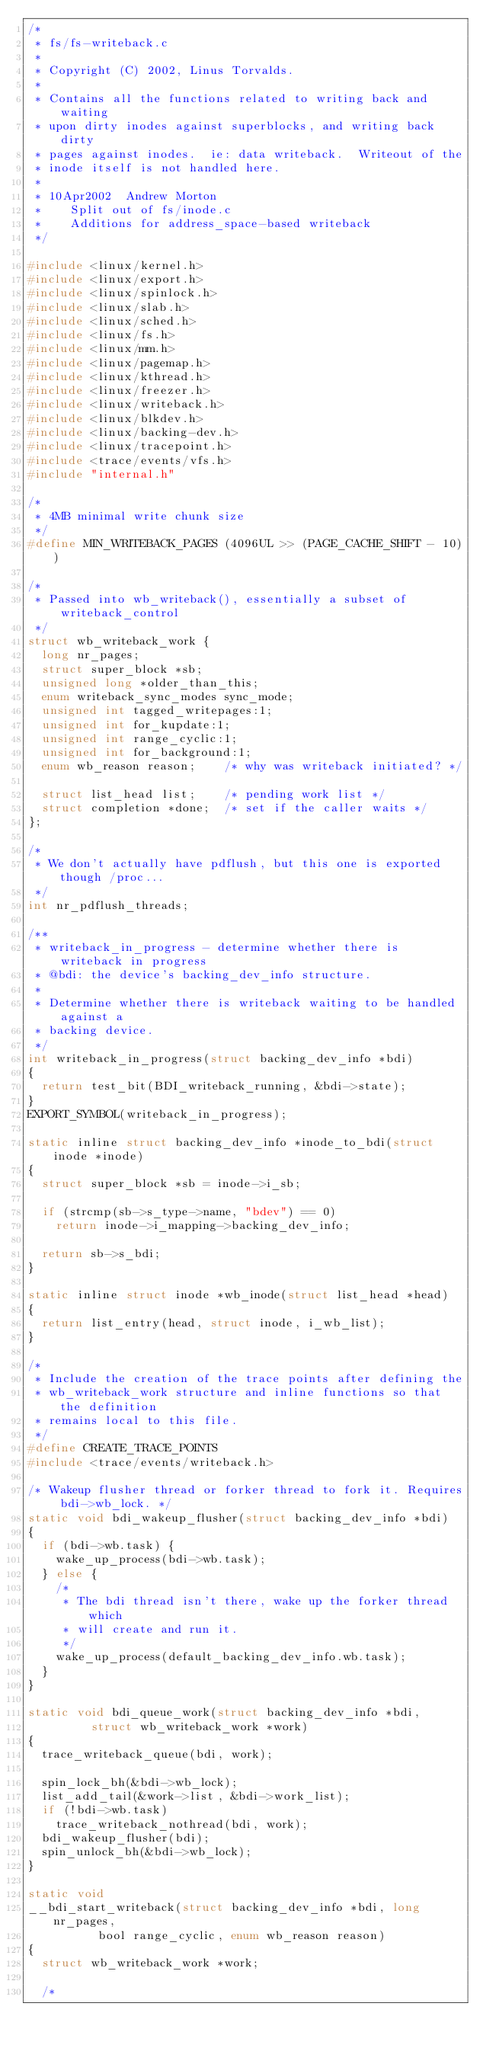Convert code to text. <code><loc_0><loc_0><loc_500><loc_500><_C_>/*
 * fs/fs-writeback.c
 *
 * Copyright (C) 2002, Linus Torvalds.
 *
 * Contains all the functions related to writing back and waiting
 * upon dirty inodes against superblocks, and writing back dirty
 * pages against inodes.  ie: data writeback.  Writeout of the
 * inode itself is not handled here.
 *
 * 10Apr2002	Andrew Morton
 *		Split out of fs/inode.c
 *		Additions for address_space-based writeback
 */

#include <linux/kernel.h>
#include <linux/export.h>
#include <linux/spinlock.h>
#include <linux/slab.h>
#include <linux/sched.h>
#include <linux/fs.h>
#include <linux/mm.h>
#include <linux/pagemap.h>
#include <linux/kthread.h>
#include <linux/freezer.h>
#include <linux/writeback.h>
#include <linux/blkdev.h>
#include <linux/backing-dev.h>
#include <linux/tracepoint.h>
#include <trace/events/vfs.h>
#include "internal.h"

/*
 * 4MB minimal write chunk size
 */
#define MIN_WRITEBACK_PAGES	(4096UL >> (PAGE_CACHE_SHIFT - 10))

/*
 * Passed into wb_writeback(), essentially a subset of writeback_control
 */
struct wb_writeback_work {
	long nr_pages;
	struct super_block *sb;
	unsigned long *older_than_this;
	enum writeback_sync_modes sync_mode;
	unsigned int tagged_writepages:1;
	unsigned int for_kupdate:1;
	unsigned int range_cyclic:1;
	unsigned int for_background:1;
	enum wb_reason reason;		/* why was writeback initiated? */

	struct list_head list;		/* pending work list */
	struct completion *done;	/* set if the caller waits */
};

/*
 * We don't actually have pdflush, but this one is exported though /proc...
 */
int nr_pdflush_threads;

/**
 * writeback_in_progress - determine whether there is writeback in progress
 * @bdi: the device's backing_dev_info structure.
 *
 * Determine whether there is writeback waiting to be handled against a
 * backing device.
 */
int writeback_in_progress(struct backing_dev_info *bdi)
{
	return test_bit(BDI_writeback_running, &bdi->state);
}
EXPORT_SYMBOL(writeback_in_progress);

static inline struct backing_dev_info *inode_to_bdi(struct inode *inode)
{
	struct super_block *sb = inode->i_sb;

	if (strcmp(sb->s_type->name, "bdev") == 0)
		return inode->i_mapping->backing_dev_info;

	return sb->s_bdi;
}

static inline struct inode *wb_inode(struct list_head *head)
{
	return list_entry(head, struct inode, i_wb_list);
}

/*
 * Include the creation of the trace points after defining the
 * wb_writeback_work structure and inline functions so that the definition
 * remains local to this file.
 */
#define CREATE_TRACE_POINTS
#include <trace/events/writeback.h>

/* Wakeup flusher thread or forker thread to fork it. Requires bdi->wb_lock. */
static void bdi_wakeup_flusher(struct backing_dev_info *bdi)
{
	if (bdi->wb.task) {
		wake_up_process(bdi->wb.task);
	} else {
		/*
		 * The bdi thread isn't there, wake up the forker thread which
		 * will create and run it.
		 */
		wake_up_process(default_backing_dev_info.wb.task);
	}
}

static void bdi_queue_work(struct backing_dev_info *bdi,
			   struct wb_writeback_work *work)
{
	trace_writeback_queue(bdi, work);

	spin_lock_bh(&bdi->wb_lock);
	list_add_tail(&work->list, &bdi->work_list);
	if (!bdi->wb.task)
		trace_writeback_nothread(bdi, work);
	bdi_wakeup_flusher(bdi);
	spin_unlock_bh(&bdi->wb_lock);
}

static void
__bdi_start_writeback(struct backing_dev_info *bdi, long nr_pages,
		      bool range_cyclic, enum wb_reason reason)
{
	struct wb_writeback_work *work;

	/*</code> 